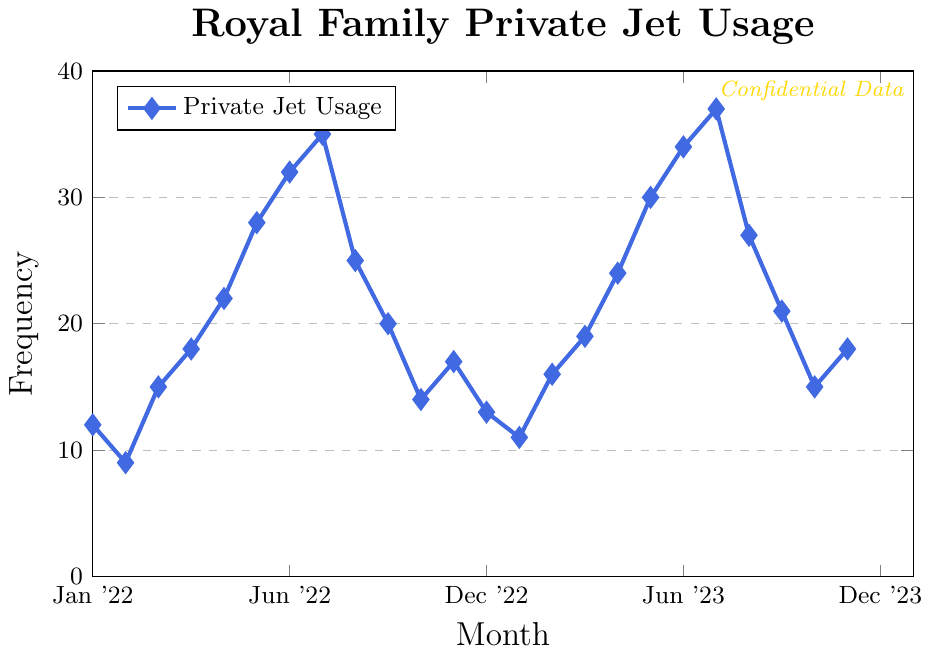What is the highest frequency of private jet usage observed on the chart? By observing the highest point on the chart, the highest value is located at the peak in August '23
Answer: 37 What month had the lowest frequency of private jet usage in 2022? By identifying the lowest point in the year 2022, it is visible in February '22
Answer: 9 How many months in 2023 had private jet usage of 30 or higher? Observing the months in 2023 with values at or above 30: Jun '23, Jul '23, Aug '23, and Sep '23
Answer: 4 In which month(s) does private jet usage decrease compared to the previous month? By observing decreases in the chart by comparing each month sequentially: Feb '22, Sep '22, Oct '22, Nov '22, Feb '23, Sep '23, Oct '23, and Nov '23
Answer: 8 What is the average private jet usage for the months shown? To calculate the average, sum all the values (12+9+15+18+22+28+32+35+25+20+14+17+13+11+16+19+24+30+34+37+27+21+15+18) = 472, then divide by the number of values (24)
Answer: 19.67 What is the difference in private jet usage between the two August months? Locate the values for August 2022 and August 2023, then subtract the former from the latter: 37 - 35
Answer: 2 Which month had a jet usage of 28? By examining the chart, the month with a value of 28 is June '22
Answer: June '22 Is the pattern of private jet usage increasing or decreasing in the first six months of 2023? By observing January through June 2023, the trend line shows an increase from 13 in Jan '23 to 30 in Jun '23
Answer: Increasing What is the total private jet usage for the months of July and August across both years? Sum the values for July and August in both years: 32+35+34+37
Answer: 138 How many months had a jet usage frequency between 15 and 25 inclusive? Counting the months where the frequency is between 15 and 25: Mar '22, May '22, Apr '23, May '23, Sep '23, Oct '23, Nov '23, Dec '23
Answer: 8 